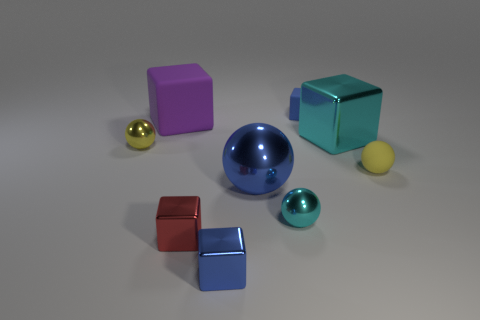Is the small yellow shiny thing the same shape as the blue rubber object?
Keep it short and to the point. No. What material is the big purple block?
Provide a succinct answer. Rubber. What number of cubes are both on the left side of the large blue thing and behind the yellow rubber object?
Make the answer very short. 1. Do the cyan cube and the purple rubber object have the same size?
Keep it short and to the point. Yes. Do the blue block that is behind the cyan sphere and the tiny red metallic cube have the same size?
Your answer should be very brief. Yes. The shiny block that is behind the yellow metallic object is what color?
Make the answer very short. Cyan. What number of blue metallic objects are there?
Your response must be concise. 2. There is a big cyan object that is made of the same material as the small red block; what shape is it?
Keep it short and to the point. Cube. There is a small ball that is in front of the big blue ball; does it have the same color as the large shiny object behind the yellow rubber object?
Ensure brevity in your answer.  Yes. Is the number of small yellow balls to the left of the large ball the same as the number of blue shiny cubes?
Make the answer very short. Yes. 